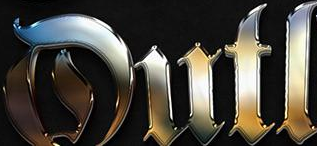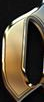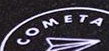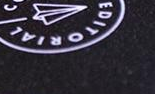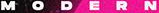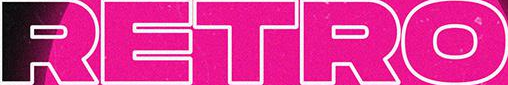What words can you see in these images in sequence, separated by a semicolon? Dutl; #; COMETA; EDITORIAL; MODERN; RETRO 